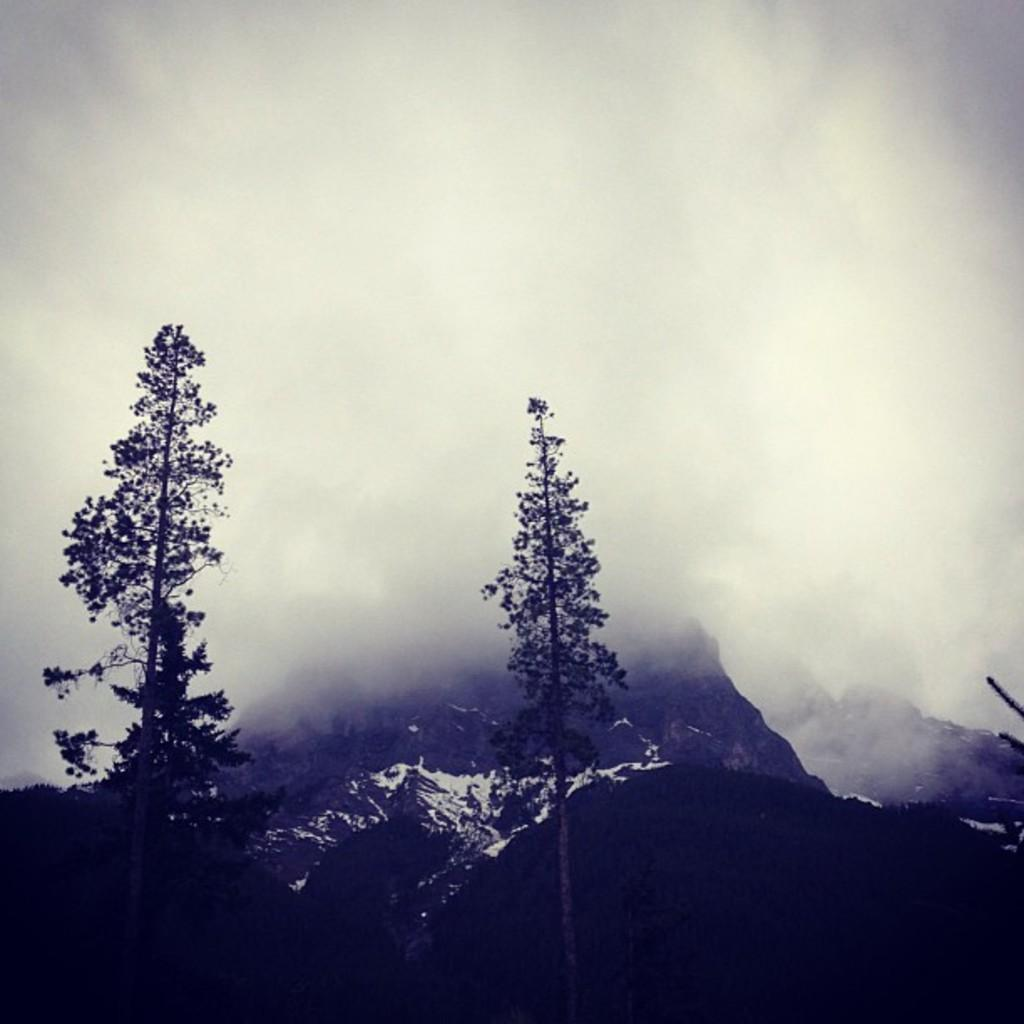What type of natural features can be seen in the image? There are trees and mountains in the image. What is the condition of the sky in the image? The sky is cloudy in the image. What day of the week is depicted in the image? The image does not depict a specific day of the week; it only shows natural features and the sky. How does the image capture the viewer's attention? The image captures the viewer's attention through the combination of trees, mountains, and the cloudy sky, but the question of how it specifically captures attention is subjective and cannot be definitively answered based on the provided facts. 